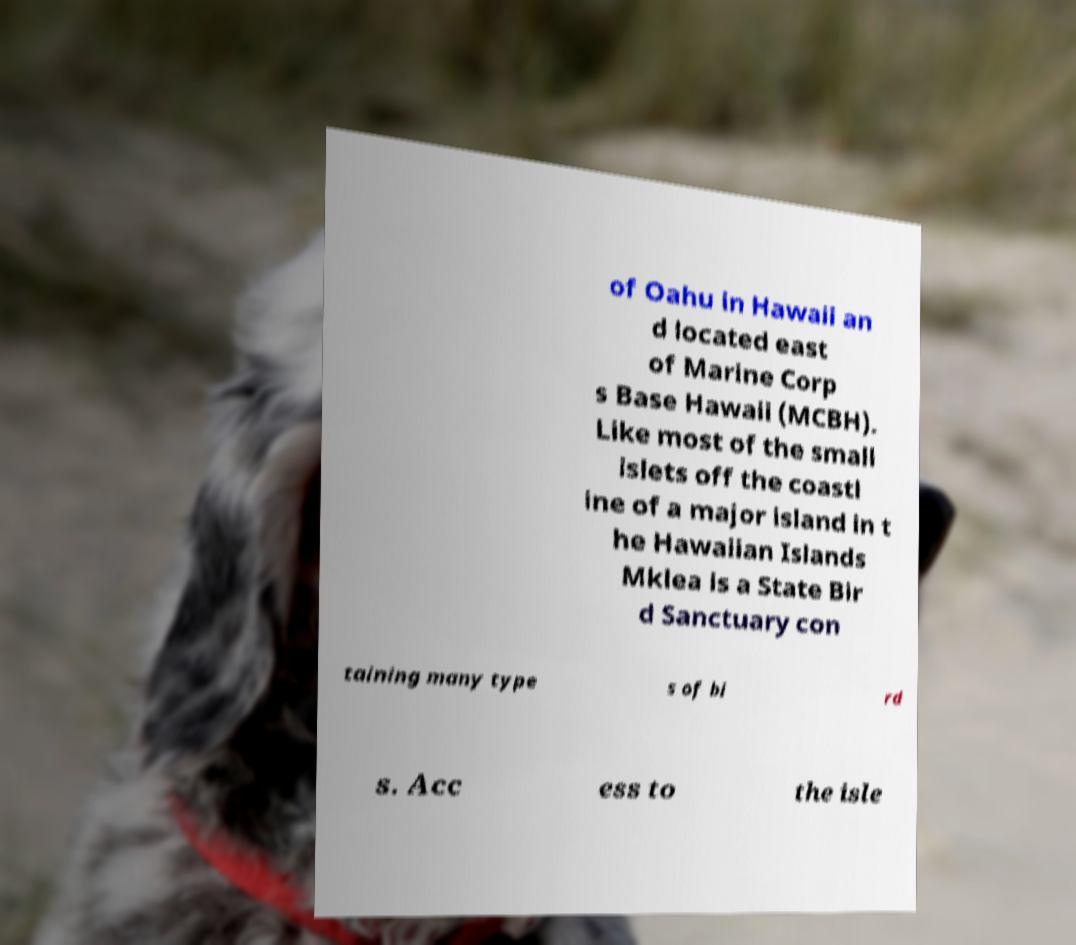What messages or text are displayed in this image? I need them in a readable, typed format. of Oahu in Hawaii an d located east of Marine Corp s Base Hawaii (MCBH). Like most of the small islets off the coastl ine of a major island in t he Hawaiian Islands Mklea is a State Bir d Sanctuary con taining many type s of bi rd s. Acc ess to the isle 